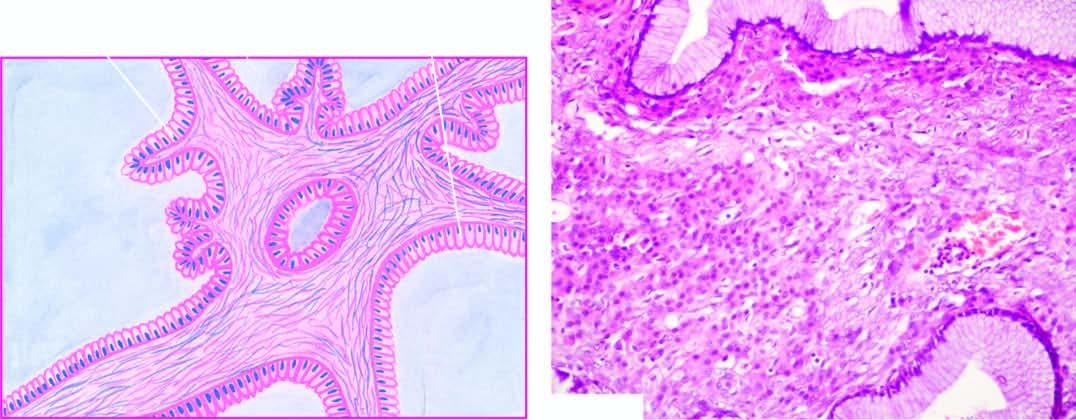re the mucosal lined by a single layer of tall columnar mucin-secreting epithelium with basally-placed nuclei and large apical mucinous vacuoles?
Answer the question using a single word or phrase. No 